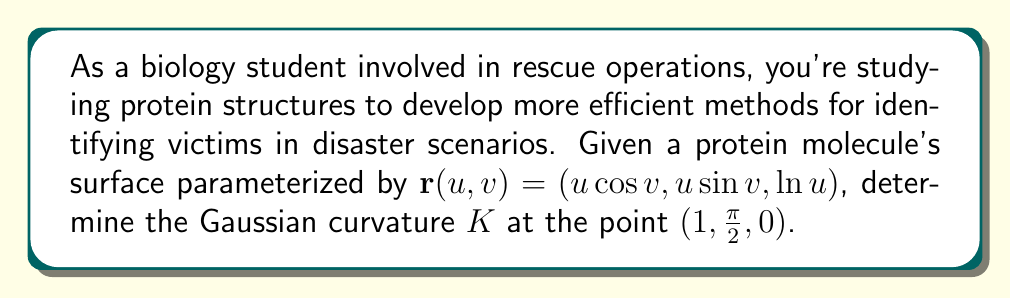Help me with this question. To find the Gaussian curvature, we need to calculate the first and second fundamental forms, then use them to compute the curvature tensor.

Step 1: Calculate the partial derivatives
$$\mathbf{r}_u = (\cos v, \sin v, \frac{1}{u})$$
$$\mathbf{r}_v = (-u\sin v, u\cos v, 0)$$
$$\mathbf{r}_{uu} = (0, 0, -\frac{1}{u^2})$$
$$\mathbf{r}_{uv} = (-\sin v, \cos v, 0)$$
$$\mathbf{r}_{vv} = (-u\cos v, -u\sin v, 0)$$

Step 2: Calculate the normal vector
$$\mathbf{N} = \frac{\mathbf{r}_u \times \mathbf{r}_v}{|\mathbf{r}_u \times \mathbf{r}_v|} = \frac{(-\sin v, -\cos v, u)}{\sqrt{u^2 + 1}}$$

Step 3: Calculate the coefficients of the first fundamental form
$$E = \mathbf{r}_u \cdot \mathbf{r}_u = 1 + \frac{1}{u^2}$$
$$F = \mathbf{r}_u \cdot \mathbf{r}_v = 0$$
$$G = \mathbf{r}_v \cdot \mathbf{r}_v = u^2$$

Step 4: Calculate the coefficients of the second fundamental form
$$e = \mathbf{r}_{uu} \cdot \mathbf{N} = \frac{1}{u\sqrt{u^2 + 1}}$$
$$f = \mathbf{r}_{uv} \cdot \mathbf{N} = 0$$
$$g = \mathbf{r}_{vv} \cdot \mathbf{N} = \frac{u^2}{\sqrt{u^2 + 1}}$$

Step 5: Calculate the Gaussian curvature
$$K = \frac{eg - f^2}{EG - F^2} = \frac{(\frac{1}{u\sqrt{u^2 + 1}})(\frac{u^2}{\sqrt{u^2 + 1}}) - 0^2}{(1 + \frac{1}{u^2})(u^2) - 0^2} = \frac{1}{u^2(u^2 + 1)}$$

Step 6: Evaluate at the point $(1,\frac{\pi}{2},0)$
At this point, $u = 1$, so:
$$K = \frac{1}{1^2(1^2 + 1)} = \frac{1}{2}$$
Answer: $K = \frac{1}{2}$ 